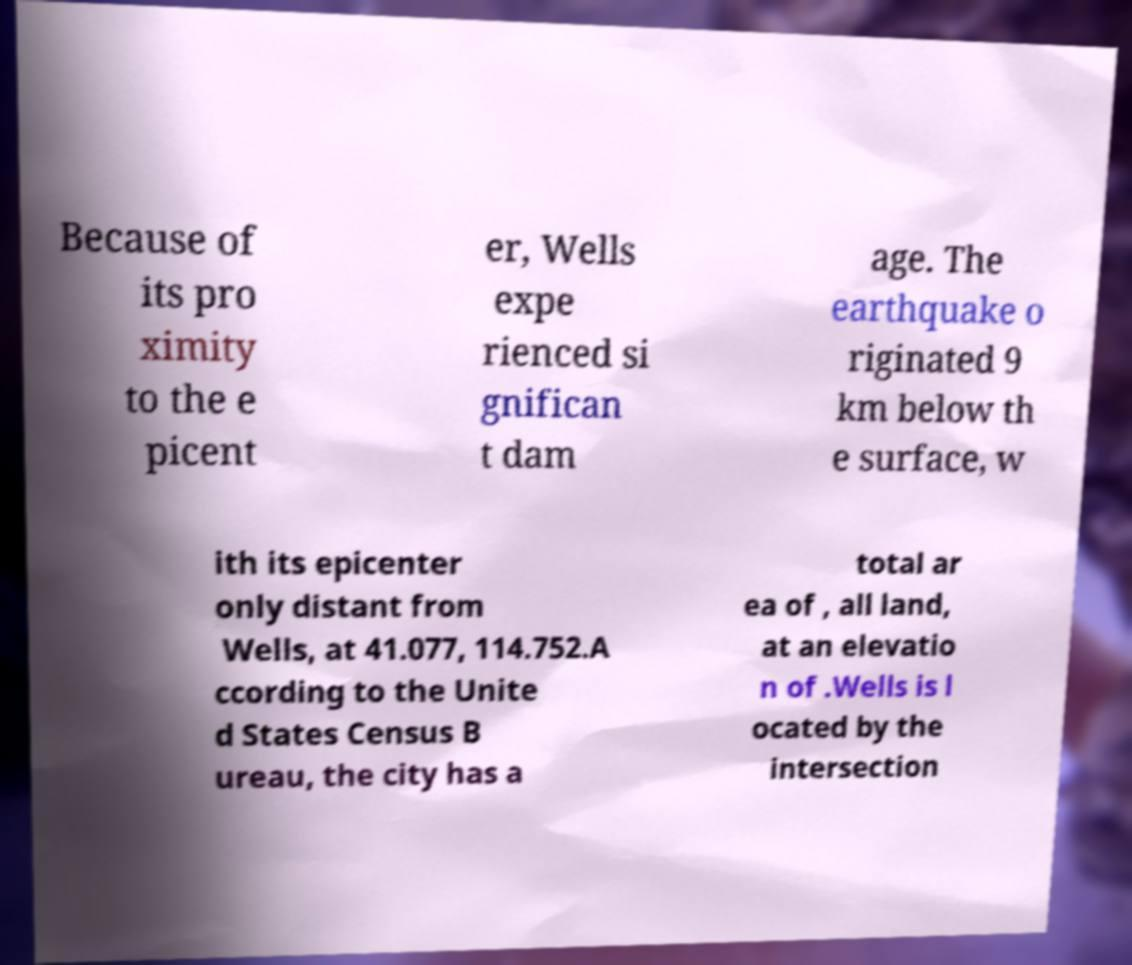I need the written content from this picture converted into text. Can you do that? Because of its pro ximity to the e picent er, Wells expe rienced si gnifican t dam age. The earthquake o riginated 9 km below th e surface, w ith its epicenter only distant from Wells, at 41.077, 114.752.A ccording to the Unite d States Census B ureau, the city has a total ar ea of , all land, at an elevatio n of .Wells is l ocated by the intersection 